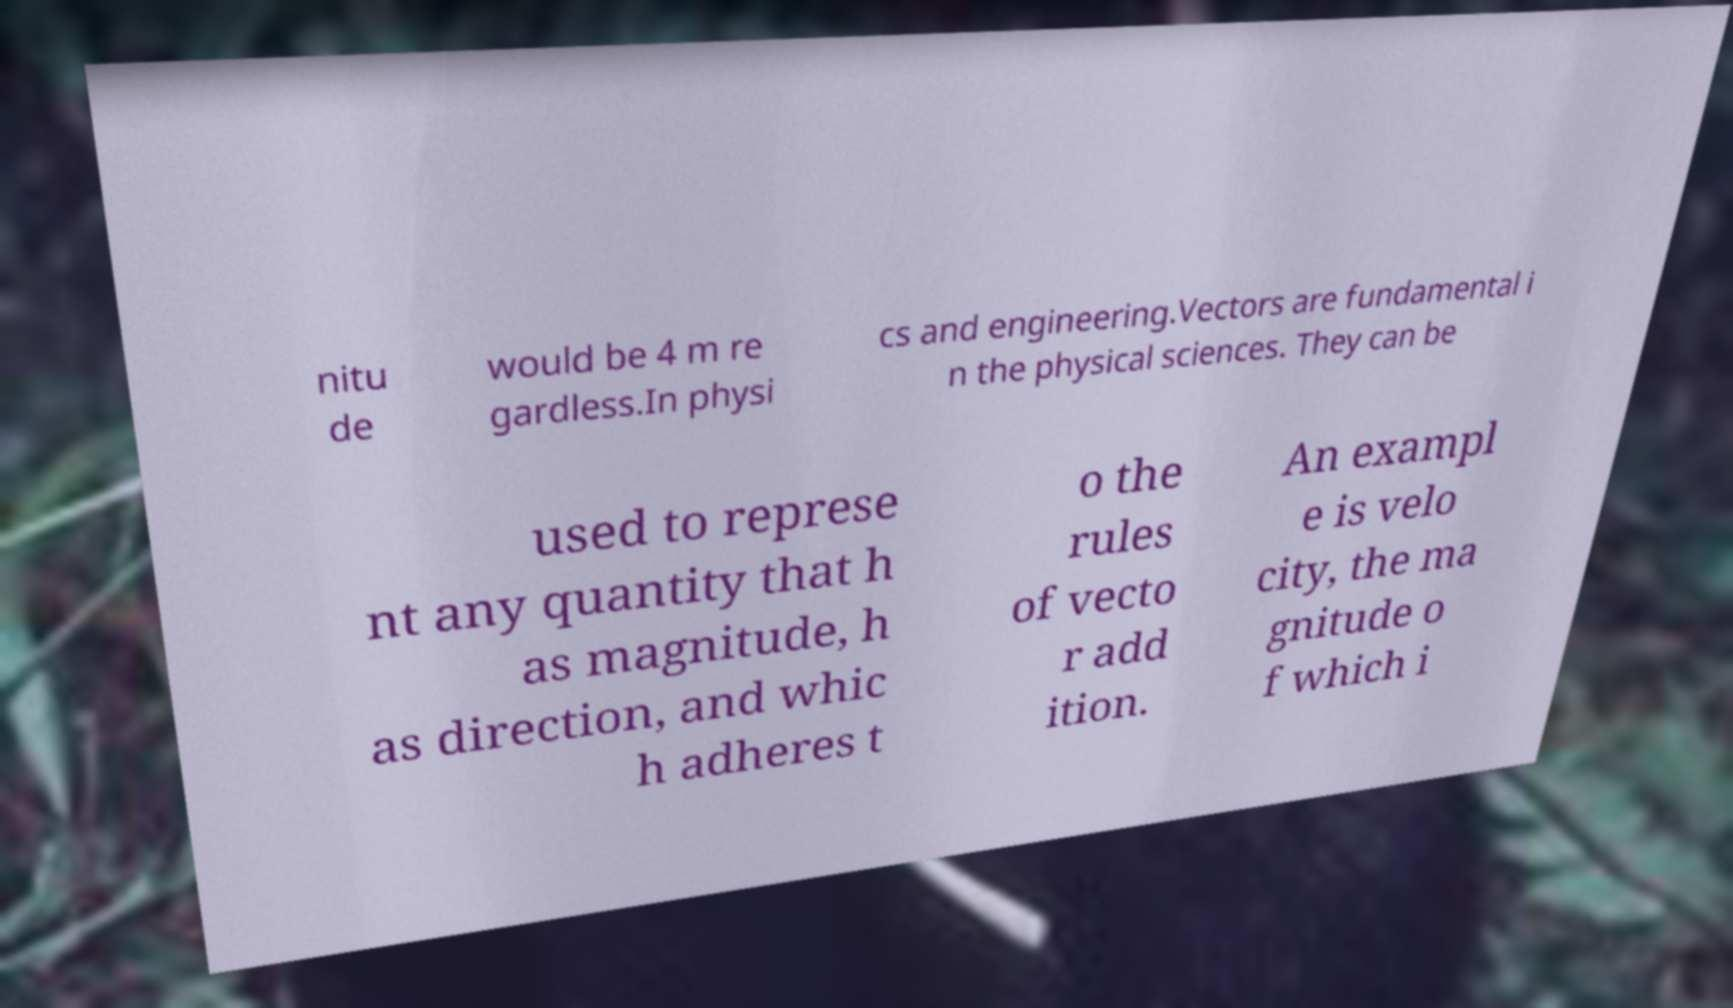Can you read and provide the text displayed in the image?This photo seems to have some interesting text. Can you extract and type it out for me? nitu de would be 4 m re gardless.In physi cs and engineering.Vectors are fundamental i n the physical sciences. They can be used to represe nt any quantity that h as magnitude, h as direction, and whic h adheres t o the rules of vecto r add ition. An exampl e is velo city, the ma gnitude o f which i 